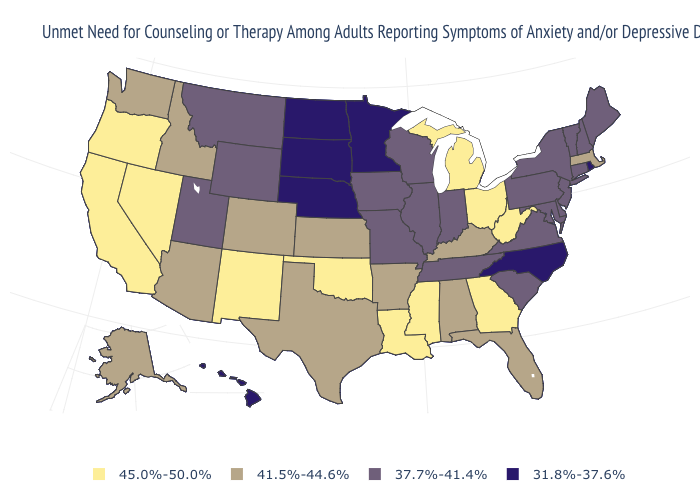Name the states that have a value in the range 37.7%-41.4%?
Short answer required. Connecticut, Delaware, Illinois, Indiana, Iowa, Maine, Maryland, Missouri, Montana, New Hampshire, New Jersey, New York, Pennsylvania, South Carolina, Tennessee, Utah, Vermont, Virginia, Wisconsin, Wyoming. What is the value of Tennessee?
Quick response, please. 37.7%-41.4%. What is the value of California?
Quick response, please. 45.0%-50.0%. Which states have the lowest value in the USA?
Write a very short answer. Hawaii, Minnesota, Nebraska, North Carolina, North Dakota, Rhode Island, South Dakota. Which states have the lowest value in the Northeast?
Answer briefly. Rhode Island. Does Tennessee have a higher value than South Dakota?
Write a very short answer. Yes. What is the value of Oregon?
Short answer required. 45.0%-50.0%. What is the value of Georgia?
Give a very brief answer. 45.0%-50.0%. What is the lowest value in states that border Kansas?
Answer briefly. 31.8%-37.6%. What is the highest value in the USA?
Concise answer only. 45.0%-50.0%. What is the lowest value in states that border Vermont?
Give a very brief answer. 37.7%-41.4%. Name the states that have a value in the range 31.8%-37.6%?
Short answer required. Hawaii, Minnesota, Nebraska, North Carolina, North Dakota, Rhode Island, South Dakota. What is the value of New Mexico?
Concise answer only. 45.0%-50.0%. Is the legend a continuous bar?
Write a very short answer. No. Which states have the highest value in the USA?
Give a very brief answer. California, Georgia, Louisiana, Michigan, Mississippi, Nevada, New Mexico, Ohio, Oklahoma, Oregon, West Virginia. 